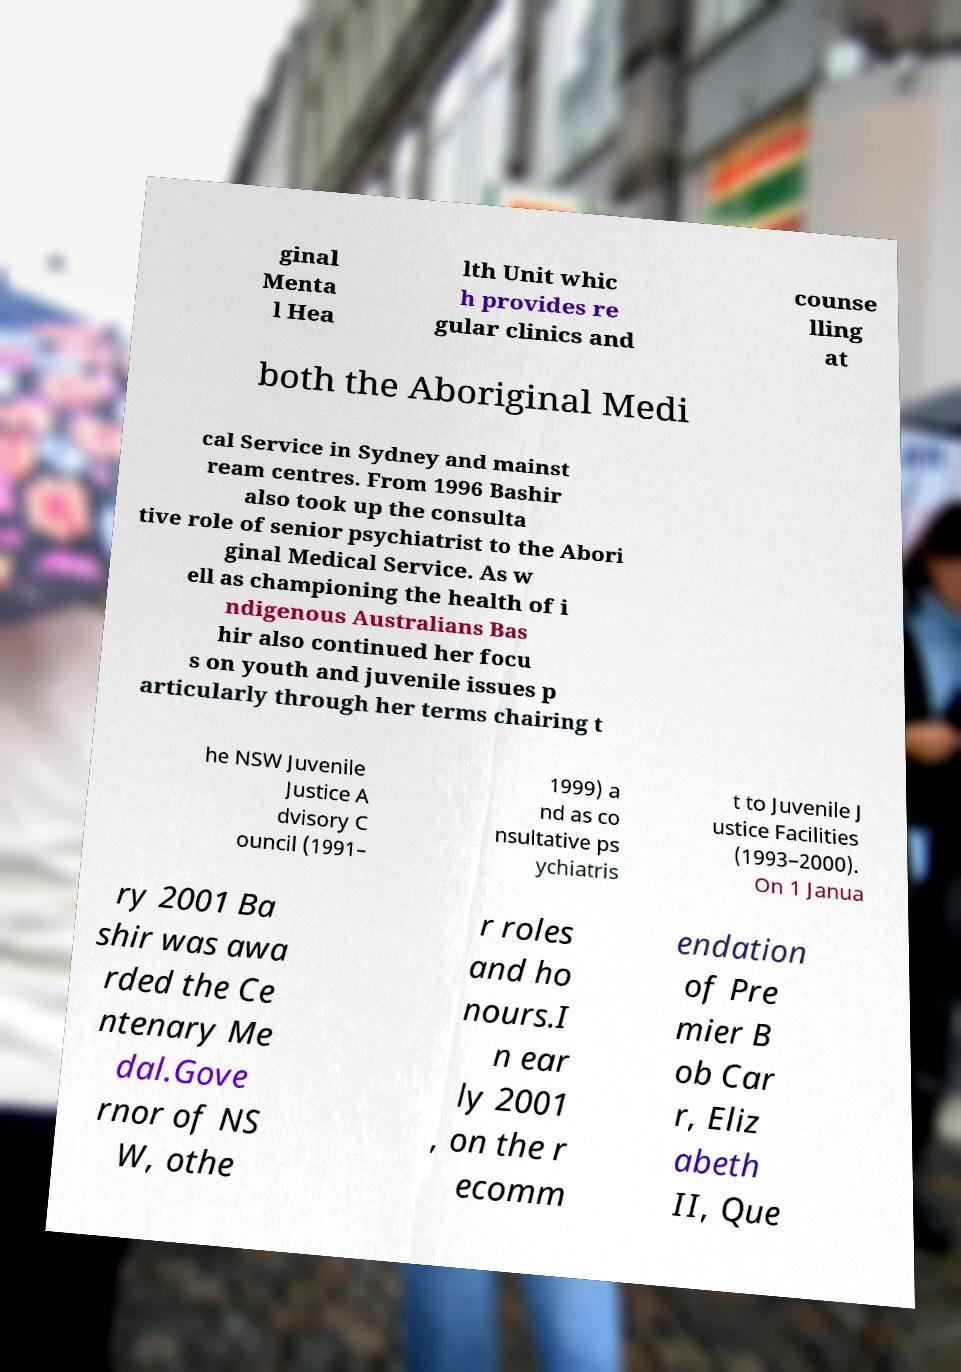Can you read and provide the text displayed in the image?This photo seems to have some interesting text. Can you extract and type it out for me? ginal Menta l Hea lth Unit whic h provides re gular clinics and counse lling at both the Aboriginal Medi cal Service in Sydney and mainst ream centres. From 1996 Bashir also took up the consulta tive role of senior psychiatrist to the Abori ginal Medical Service. As w ell as championing the health of i ndigenous Australians Bas hir also continued her focu s on youth and juvenile issues p articularly through her terms chairing t he NSW Juvenile Justice A dvisory C ouncil (1991– 1999) a nd as co nsultative ps ychiatris t to Juvenile J ustice Facilities (1993–2000). On 1 Janua ry 2001 Ba shir was awa rded the Ce ntenary Me dal.Gove rnor of NS W, othe r roles and ho nours.I n ear ly 2001 , on the r ecomm endation of Pre mier B ob Car r, Eliz abeth II, Que 